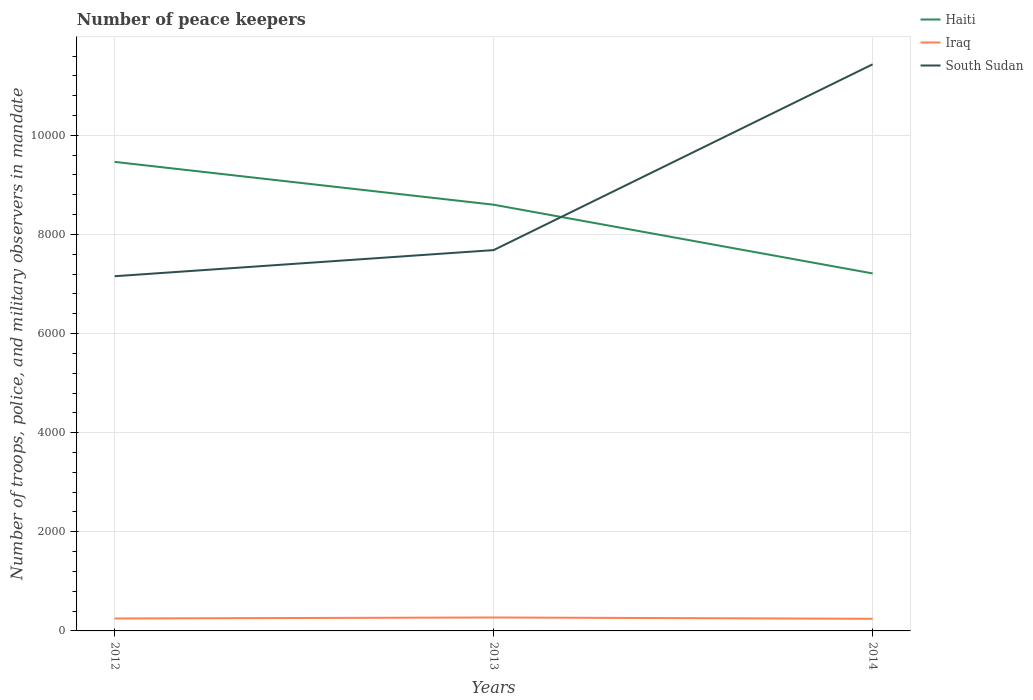Does the line corresponding to Iraq intersect with the line corresponding to Haiti?
Provide a succinct answer. No. Is the number of lines equal to the number of legend labels?
Your answer should be very brief. Yes. Across all years, what is the maximum number of peace keepers in in South Sudan?
Your response must be concise. 7157. In which year was the number of peace keepers in in Iraq maximum?
Give a very brief answer. 2014. What is the total number of peace keepers in in Iraq in the graph?
Keep it short and to the point. -20. What is the difference between the highest and the second highest number of peace keepers in in South Sudan?
Make the answer very short. 4276. Is the number of peace keepers in in Iraq strictly greater than the number of peace keepers in in Haiti over the years?
Your answer should be very brief. Yes. How many lines are there?
Offer a terse response. 3. How many years are there in the graph?
Offer a very short reply. 3. What is the difference between two consecutive major ticks on the Y-axis?
Ensure brevity in your answer.  2000. Are the values on the major ticks of Y-axis written in scientific E-notation?
Provide a short and direct response. No. Does the graph contain grids?
Your answer should be compact. Yes. Where does the legend appear in the graph?
Keep it short and to the point. Top right. What is the title of the graph?
Make the answer very short. Number of peace keepers. What is the label or title of the Y-axis?
Make the answer very short. Number of troops, police, and military observers in mandate. What is the Number of troops, police, and military observers in mandate in Haiti in 2012?
Offer a terse response. 9464. What is the Number of troops, police, and military observers in mandate of Iraq in 2012?
Offer a very short reply. 251. What is the Number of troops, police, and military observers in mandate of South Sudan in 2012?
Offer a terse response. 7157. What is the Number of troops, police, and military observers in mandate in Haiti in 2013?
Offer a terse response. 8600. What is the Number of troops, police, and military observers in mandate in Iraq in 2013?
Your answer should be compact. 271. What is the Number of troops, police, and military observers in mandate in South Sudan in 2013?
Your response must be concise. 7684. What is the Number of troops, police, and military observers in mandate of Haiti in 2014?
Keep it short and to the point. 7213. What is the Number of troops, police, and military observers in mandate in Iraq in 2014?
Offer a very short reply. 245. What is the Number of troops, police, and military observers in mandate of South Sudan in 2014?
Keep it short and to the point. 1.14e+04. Across all years, what is the maximum Number of troops, police, and military observers in mandate of Haiti?
Keep it short and to the point. 9464. Across all years, what is the maximum Number of troops, police, and military observers in mandate in Iraq?
Provide a short and direct response. 271. Across all years, what is the maximum Number of troops, police, and military observers in mandate of South Sudan?
Offer a very short reply. 1.14e+04. Across all years, what is the minimum Number of troops, police, and military observers in mandate of Haiti?
Make the answer very short. 7213. Across all years, what is the minimum Number of troops, police, and military observers in mandate in Iraq?
Provide a succinct answer. 245. Across all years, what is the minimum Number of troops, police, and military observers in mandate in South Sudan?
Ensure brevity in your answer.  7157. What is the total Number of troops, police, and military observers in mandate of Haiti in the graph?
Your answer should be very brief. 2.53e+04. What is the total Number of troops, police, and military observers in mandate of Iraq in the graph?
Provide a short and direct response. 767. What is the total Number of troops, police, and military observers in mandate of South Sudan in the graph?
Offer a very short reply. 2.63e+04. What is the difference between the Number of troops, police, and military observers in mandate of Haiti in 2012 and that in 2013?
Provide a succinct answer. 864. What is the difference between the Number of troops, police, and military observers in mandate of South Sudan in 2012 and that in 2013?
Give a very brief answer. -527. What is the difference between the Number of troops, police, and military observers in mandate of Haiti in 2012 and that in 2014?
Your response must be concise. 2251. What is the difference between the Number of troops, police, and military observers in mandate in South Sudan in 2012 and that in 2014?
Give a very brief answer. -4276. What is the difference between the Number of troops, police, and military observers in mandate in Haiti in 2013 and that in 2014?
Provide a short and direct response. 1387. What is the difference between the Number of troops, police, and military observers in mandate in Iraq in 2013 and that in 2014?
Keep it short and to the point. 26. What is the difference between the Number of troops, police, and military observers in mandate in South Sudan in 2013 and that in 2014?
Offer a very short reply. -3749. What is the difference between the Number of troops, police, and military observers in mandate of Haiti in 2012 and the Number of troops, police, and military observers in mandate of Iraq in 2013?
Make the answer very short. 9193. What is the difference between the Number of troops, police, and military observers in mandate in Haiti in 2012 and the Number of troops, police, and military observers in mandate in South Sudan in 2013?
Give a very brief answer. 1780. What is the difference between the Number of troops, police, and military observers in mandate of Iraq in 2012 and the Number of troops, police, and military observers in mandate of South Sudan in 2013?
Keep it short and to the point. -7433. What is the difference between the Number of troops, police, and military observers in mandate in Haiti in 2012 and the Number of troops, police, and military observers in mandate in Iraq in 2014?
Your response must be concise. 9219. What is the difference between the Number of troops, police, and military observers in mandate in Haiti in 2012 and the Number of troops, police, and military observers in mandate in South Sudan in 2014?
Your response must be concise. -1969. What is the difference between the Number of troops, police, and military observers in mandate in Iraq in 2012 and the Number of troops, police, and military observers in mandate in South Sudan in 2014?
Your answer should be compact. -1.12e+04. What is the difference between the Number of troops, police, and military observers in mandate in Haiti in 2013 and the Number of troops, police, and military observers in mandate in Iraq in 2014?
Your response must be concise. 8355. What is the difference between the Number of troops, police, and military observers in mandate in Haiti in 2013 and the Number of troops, police, and military observers in mandate in South Sudan in 2014?
Your answer should be compact. -2833. What is the difference between the Number of troops, police, and military observers in mandate in Iraq in 2013 and the Number of troops, police, and military observers in mandate in South Sudan in 2014?
Provide a short and direct response. -1.12e+04. What is the average Number of troops, police, and military observers in mandate in Haiti per year?
Keep it short and to the point. 8425.67. What is the average Number of troops, police, and military observers in mandate in Iraq per year?
Provide a succinct answer. 255.67. What is the average Number of troops, police, and military observers in mandate in South Sudan per year?
Offer a terse response. 8758. In the year 2012, what is the difference between the Number of troops, police, and military observers in mandate in Haiti and Number of troops, police, and military observers in mandate in Iraq?
Give a very brief answer. 9213. In the year 2012, what is the difference between the Number of troops, police, and military observers in mandate in Haiti and Number of troops, police, and military observers in mandate in South Sudan?
Offer a very short reply. 2307. In the year 2012, what is the difference between the Number of troops, police, and military observers in mandate in Iraq and Number of troops, police, and military observers in mandate in South Sudan?
Keep it short and to the point. -6906. In the year 2013, what is the difference between the Number of troops, police, and military observers in mandate in Haiti and Number of troops, police, and military observers in mandate in Iraq?
Your answer should be compact. 8329. In the year 2013, what is the difference between the Number of troops, police, and military observers in mandate of Haiti and Number of troops, police, and military observers in mandate of South Sudan?
Provide a short and direct response. 916. In the year 2013, what is the difference between the Number of troops, police, and military observers in mandate of Iraq and Number of troops, police, and military observers in mandate of South Sudan?
Offer a very short reply. -7413. In the year 2014, what is the difference between the Number of troops, police, and military observers in mandate of Haiti and Number of troops, police, and military observers in mandate of Iraq?
Make the answer very short. 6968. In the year 2014, what is the difference between the Number of troops, police, and military observers in mandate in Haiti and Number of troops, police, and military observers in mandate in South Sudan?
Keep it short and to the point. -4220. In the year 2014, what is the difference between the Number of troops, police, and military observers in mandate of Iraq and Number of troops, police, and military observers in mandate of South Sudan?
Keep it short and to the point. -1.12e+04. What is the ratio of the Number of troops, police, and military observers in mandate in Haiti in 2012 to that in 2013?
Your response must be concise. 1.1. What is the ratio of the Number of troops, police, and military observers in mandate of Iraq in 2012 to that in 2013?
Your answer should be very brief. 0.93. What is the ratio of the Number of troops, police, and military observers in mandate in South Sudan in 2012 to that in 2013?
Offer a terse response. 0.93. What is the ratio of the Number of troops, police, and military observers in mandate in Haiti in 2012 to that in 2014?
Offer a very short reply. 1.31. What is the ratio of the Number of troops, police, and military observers in mandate in Iraq in 2012 to that in 2014?
Offer a terse response. 1.02. What is the ratio of the Number of troops, police, and military observers in mandate in South Sudan in 2012 to that in 2014?
Offer a very short reply. 0.63. What is the ratio of the Number of troops, police, and military observers in mandate in Haiti in 2013 to that in 2014?
Ensure brevity in your answer.  1.19. What is the ratio of the Number of troops, police, and military observers in mandate of Iraq in 2013 to that in 2014?
Offer a very short reply. 1.11. What is the ratio of the Number of troops, police, and military observers in mandate of South Sudan in 2013 to that in 2014?
Make the answer very short. 0.67. What is the difference between the highest and the second highest Number of troops, police, and military observers in mandate in Haiti?
Your answer should be very brief. 864. What is the difference between the highest and the second highest Number of troops, police, and military observers in mandate of South Sudan?
Provide a succinct answer. 3749. What is the difference between the highest and the lowest Number of troops, police, and military observers in mandate of Haiti?
Your answer should be compact. 2251. What is the difference between the highest and the lowest Number of troops, police, and military observers in mandate in Iraq?
Ensure brevity in your answer.  26. What is the difference between the highest and the lowest Number of troops, police, and military observers in mandate in South Sudan?
Offer a terse response. 4276. 